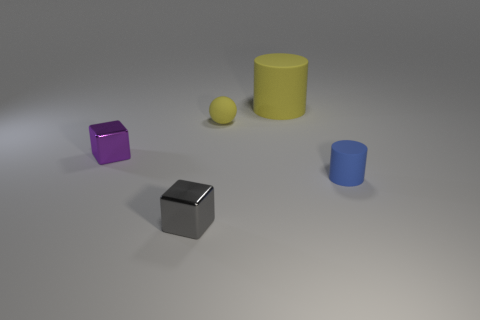What is the size of the ball that is the same color as the big cylinder?
Your answer should be very brief. Small. What number of other objects are there of the same color as the tiny matte sphere?
Your answer should be very brief. 1. Does the rubber sphere have the same color as the large object?
Your answer should be very brief. Yes. What number of objects are either tiny matte objects left of the yellow matte cylinder or tiny gray things?
Give a very brief answer. 2. What is the shape of the purple thing that is the same size as the gray metal object?
Offer a very short reply. Cube. Does the thing that is in front of the small blue matte cylinder have the same size as the rubber cylinder in front of the tiny yellow matte ball?
Your response must be concise. Yes. There is a big cylinder that is made of the same material as the yellow ball; what is its color?
Ensure brevity in your answer.  Yellow. Does the block that is in front of the purple metallic cube have the same material as the cylinder behind the yellow sphere?
Your answer should be very brief. No. Is there a blue rubber cylinder that has the same size as the gray shiny cube?
Give a very brief answer. Yes. There is a rubber cylinder that is to the left of the blue thing in front of the yellow sphere; what size is it?
Your answer should be very brief. Large. 